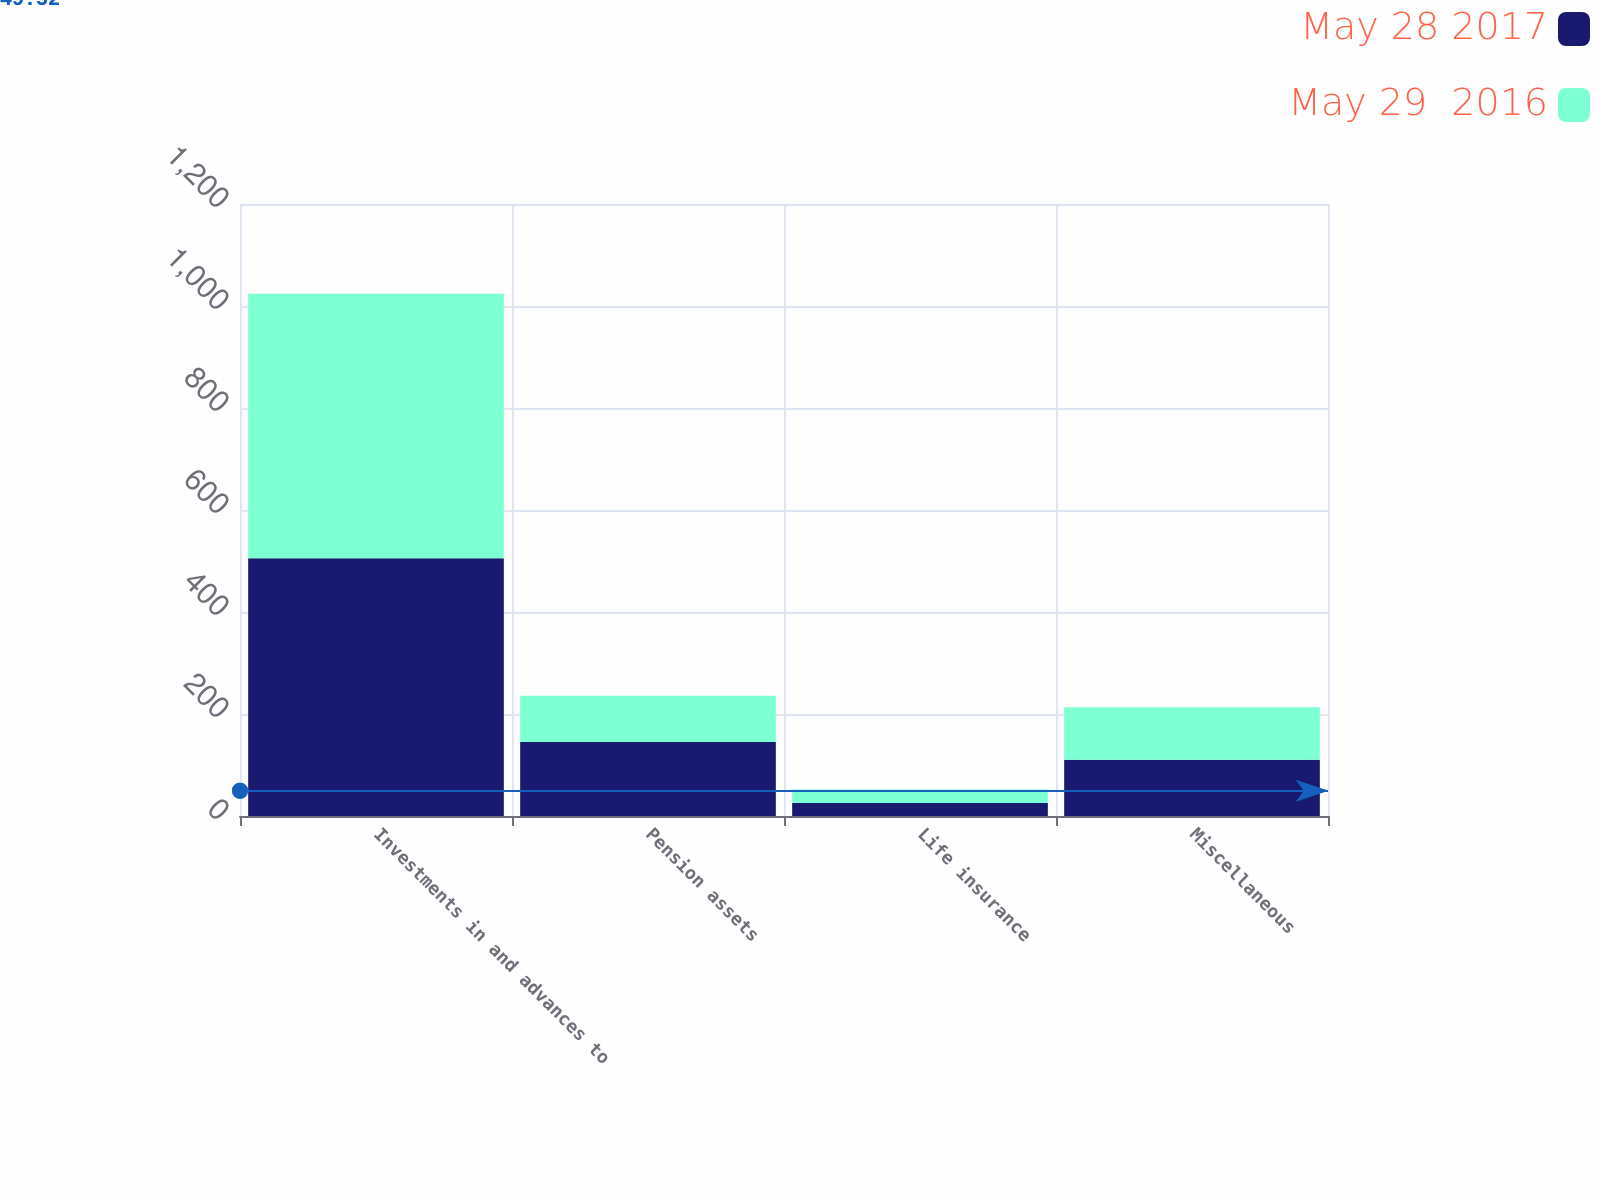Convert chart to OTSL. <chart><loc_0><loc_0><loc_500><loc_500><stacked_bar_chart><ecel><fcel>Investments in and advances to<fcel>Pension assets<fcel>Life insurance<fcel>Miscellaneous<nl><fcel>May 28 2017<fcel>505.3<fcel>144.9<fcel>25.6<fcel>110.1<nl><fcel>May 29  2016<fcel>518.9<fcel>90.9<fcel>26.3<fcel>102.9<nl></chart> 